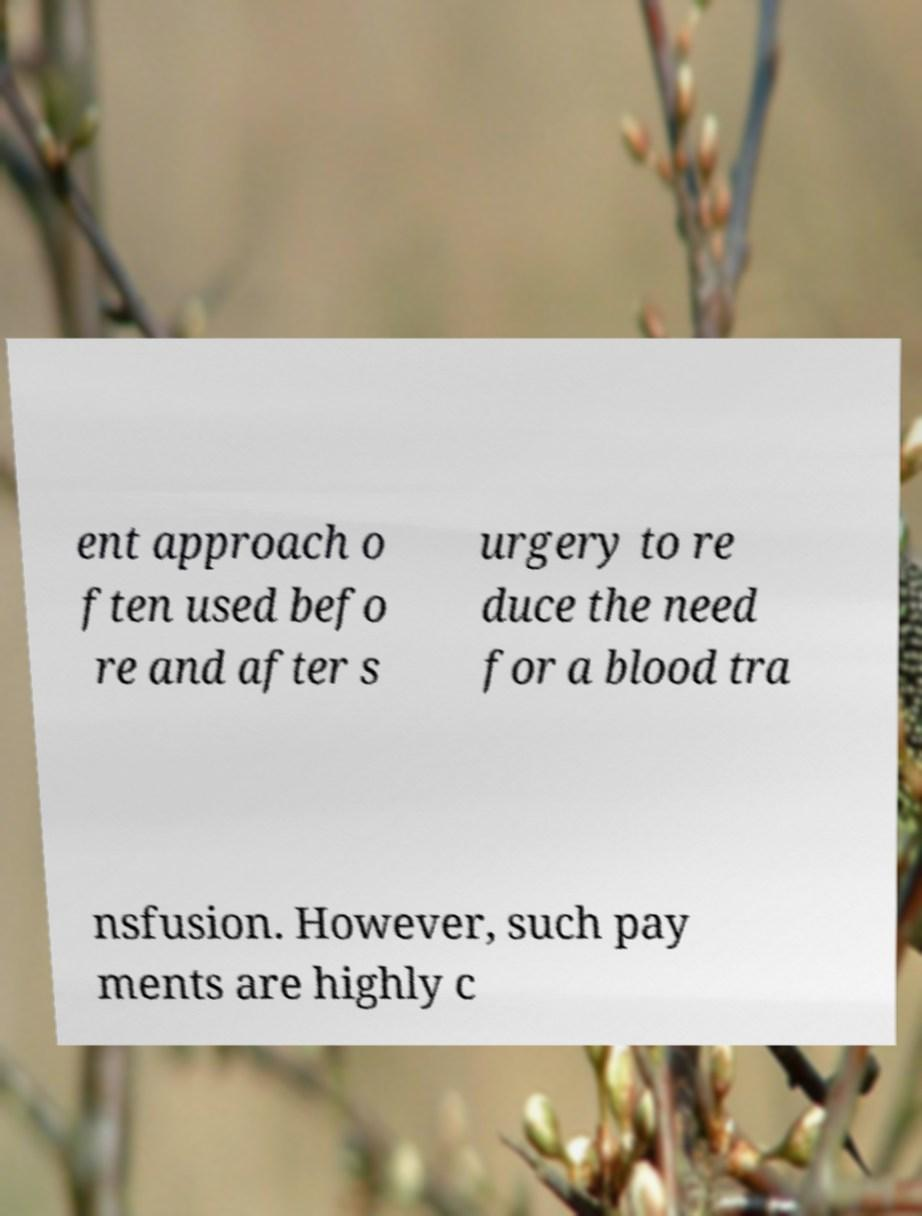Can you read and provide the text displayed in the image?This photo seems to have some interesting text. Can you extract and type it out for me? ent approach o ften used befo re and after s urgery to re duce the need for a blood tra nsfusion. However, such pay ments are highly c 